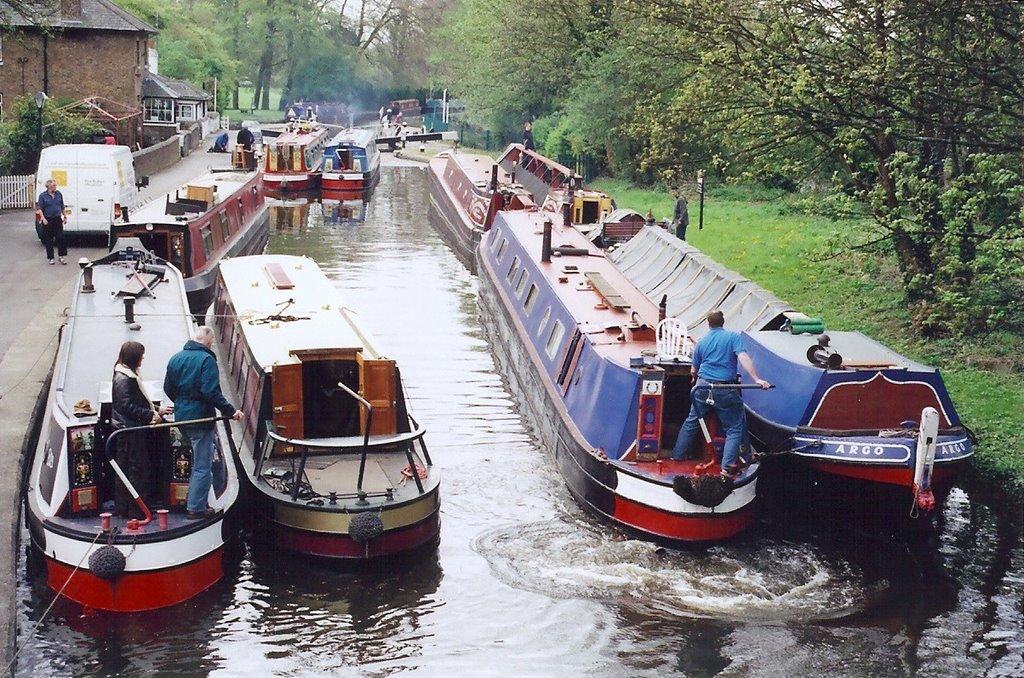What is the name of the boat on the right?
Give a very brief answer. Argo. 